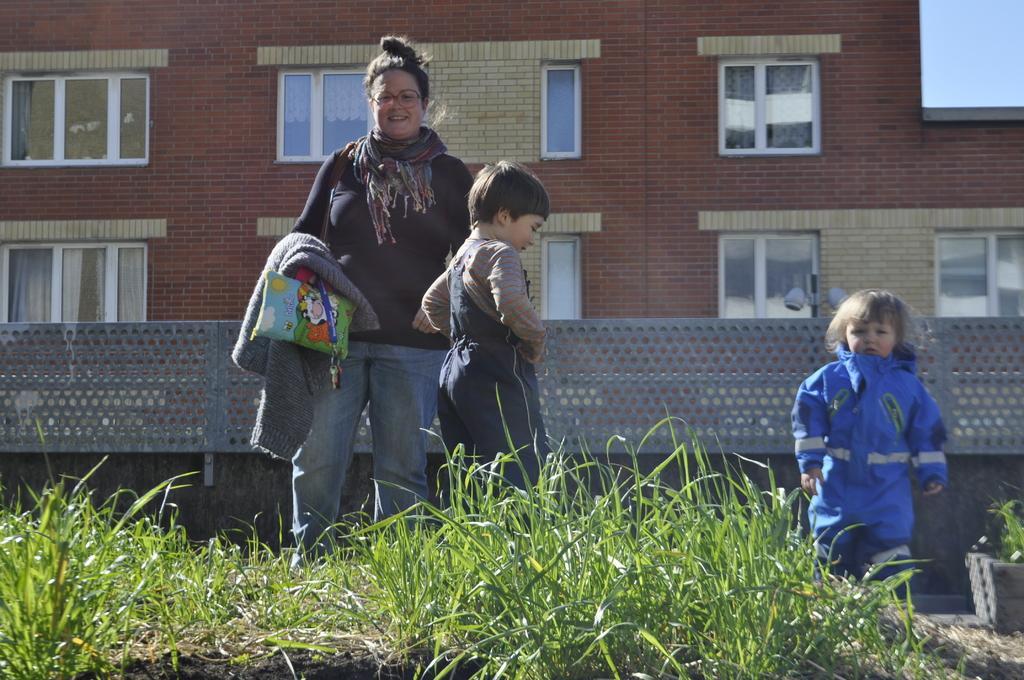Can you describe this image briefly? In this picture we can see there are three people standing and in front of the people there is grass. Behind the people, there is a wall and a building. In front of the building, it looks like a pole with lights. On the right side of the building there is the sky. 